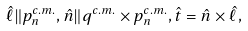<formula> <loc_0><loc_0><loc_500><loc_500>\hat { \ell } \| { p } ^ { c . m . } _ { n } , \hat { n } \| { q } ^ { c . m . } \times { p } ^ { c . m . } _ { n } , \hat { t } = \hat { n } \times \hat { \ell } ,</formula> 